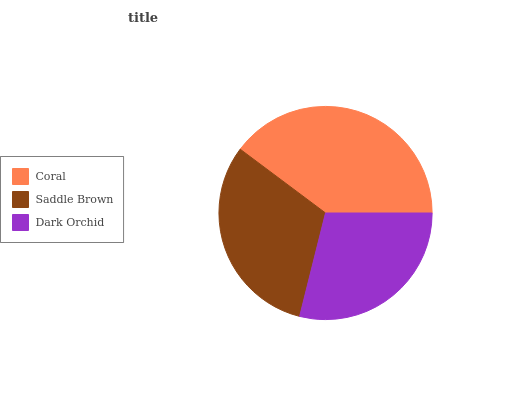Is Dark Orchid the minimum?
Answer yes or no. Yes. Is Coral the maximum?
Answer yes or no. Yes. Is Saddle Brown the minimum?
Answer yes or no. No. Is Saddle Brown the maximum?
Answer yes or no. No. Is Coral greater than Saddle Brown?
Answer yes or no. Yes. Is Saddle Brown less than Coral?
Answer yes or no. Yes. Is Saddle Brown greater than Coral?
Answer yes or no. No. Is Coral less than Saddle Brown?
Answer yes or no. No. Is Saddle Brown the high median?
Answer yes or no. Yes. Is Saddle Brown the low median?
Answer yes or no. Yes. Is Coral the high median?
Answer yes or no. No. Is Coral the low median?
Answer yes or no. No. 